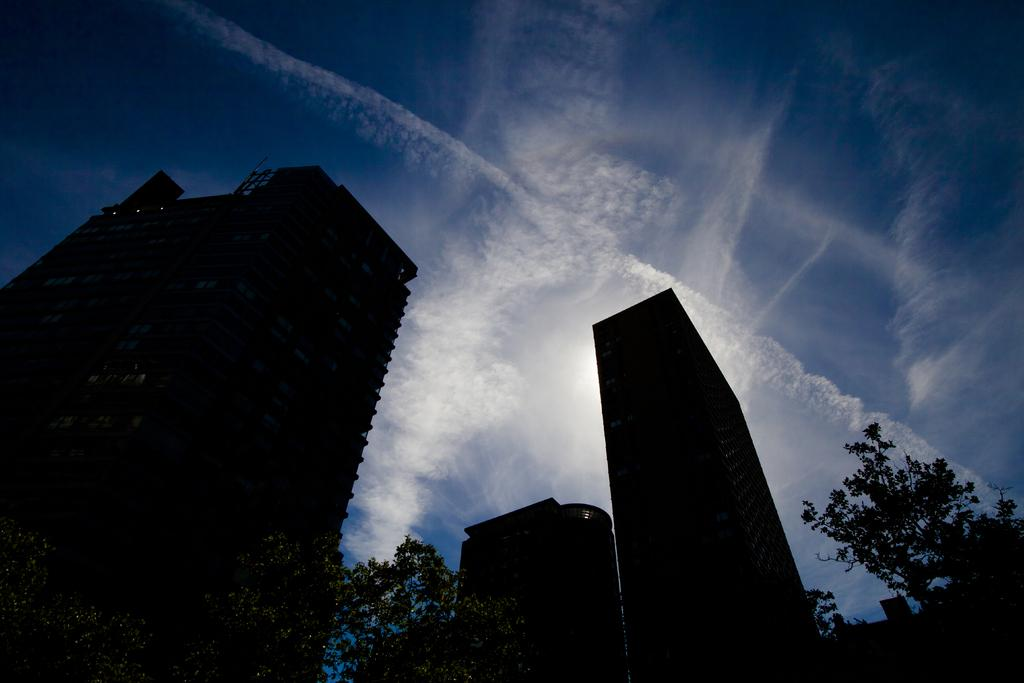What type of structures can be seen in the image? A: There are buildings in the image. What other natural elements are present in the image? There are trees in the image. What can be seen in the background of the image? The sky is visible in the background of the image. What is the condition of the sky in the image? There are clouds in the sky. How many icicles are hanging from the trees in the image? There are no icicles present in the image, as it is not a winter scene. Can you spot a rat hiding among the trees in the image? There is no rat present in the image; it only features buildings, trees, and the sky. 